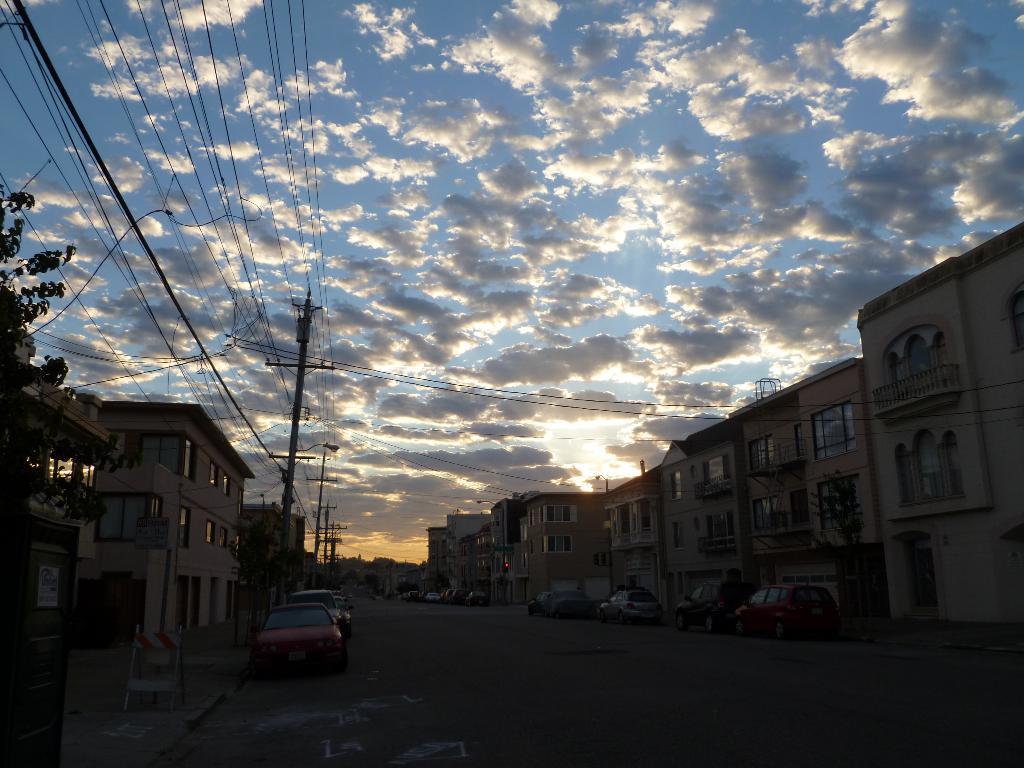Describe this image in one or two sentences. On the left side, there are poles having electric lines, there are trees, buildings and a footpath. On the right side, there is a road on which there are vehicles. In the background, there are buildings, trees and there are clouds in the sky. 